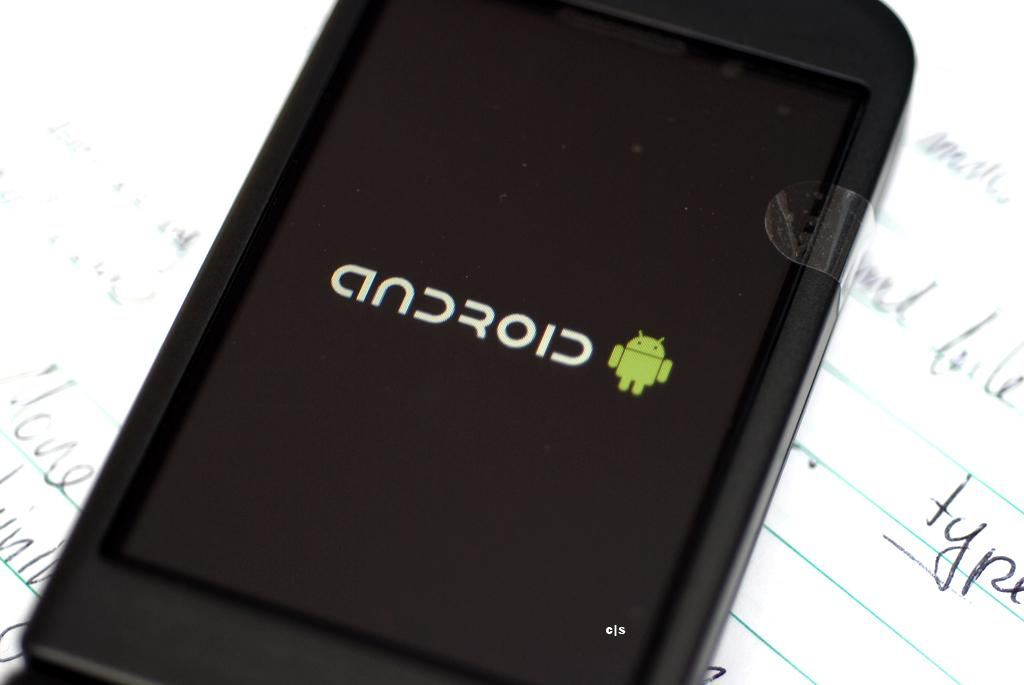Provide a one-sentence caption for the provided image. A smartphone resting on a sheet of lined paper showing the android logo on its screen. 